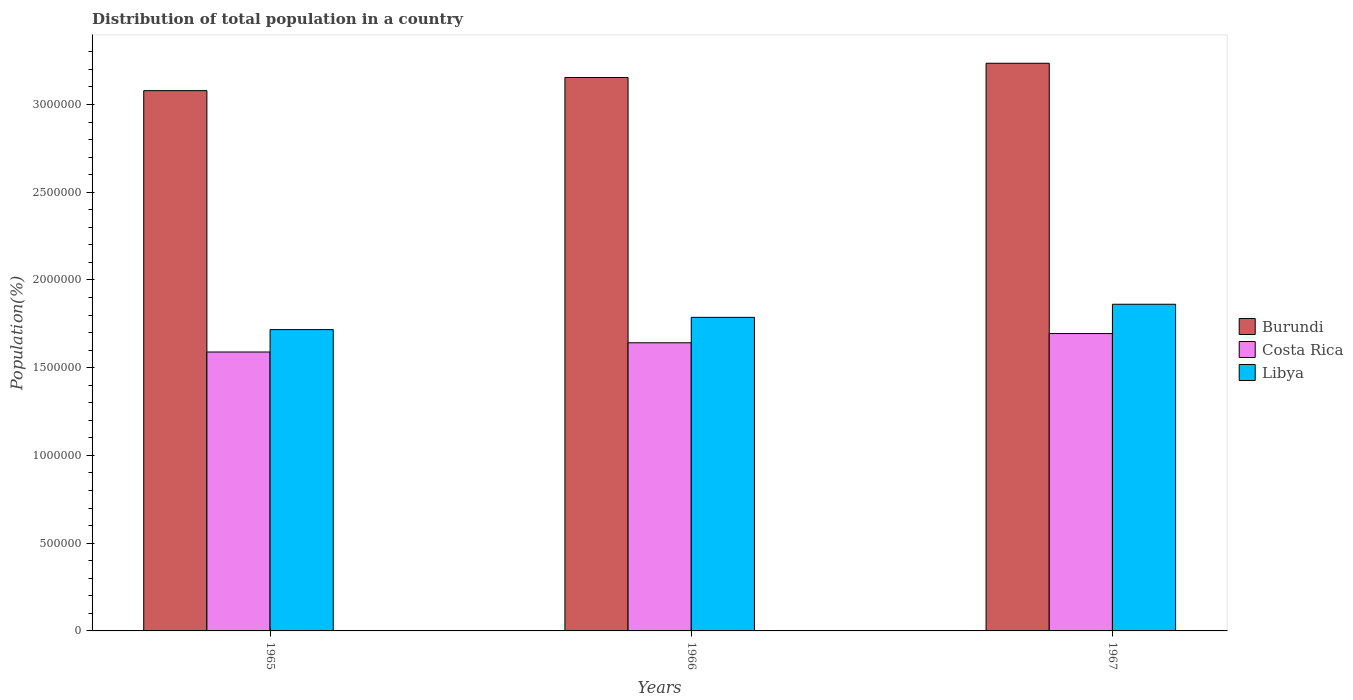How many different coloured bars are there?
Offer a very short reply. 3. Are the number of bars per tick equal to the number of legend labels?
Offer a terse response. Yes. What is the label of the 3rd group of bars from the left?
Offer a terse response. 1967. In how many cases, is the number of bars for a given year not equal to the number of legend labels?
Offer a terse response. 0. What is the population of in Burundi in 1965?
Offer a very short reply. 3.08e+06. Across all years, what is the maximum population of in Costa Rica?
Provide a short and direct response. 1.69e+06. Across all years, what is the minimum population of in Burundi?
Keep it short and to the point. 3.08e+06. In which year was the population of in Costa Rica maximum?
Offer a terse response. 1967. In which year was the population of in Costa Rica minimum?
Make the answer very short. 1965. What is the total population of in Costa Rica in the graph?
Offer a very short reply. 4.93e+06. What is the difference between the population of in Costa Rica in 1965 and that in 1966?
Provide a succinct answer. -5.26e+04. What is the difference between the population of in Costa Rica in 1965 and the population of in Libya in 1967?
Make the answer very short. -2.72e+05. What is the average population of in Libya per year?
Keep it short and to the point. 1.79e+06. In the year 1966, what is the difference between the population of in Libya and population of in Burundi?
Your answer should be compact. -1.37e+06. In how many years, is the population of in Burundi greater than 600000 %?
Your answer should be very brief. 3. What is the ratio of the population of in Costa Rica in 1966 to that in 1967?
Offer a terse response. 0.97. What is the difference between the highest and the second highest population of in Costa Rica?
Give a very brief answer. 5.25e+04. What is the difference between the highest and the lowest population of in Libya?
Your answer should be very brief. 1.44e+05. In how many years, is the population of in Burundi greater than the average population of in Burundi taken over all years?
Your answer should be compact. 1. What does the 1st bar from the left in 1965 represents?
Offer a very short reply. Burundi. What does the 1st bar from the right in 1967 represents?
Give a very brief answer. Libya. Is it the case that in every year, the sum of the population of in Libya and population of in Costa Rica is greater than the population of in Burundi?
Make the answer very short. Yes. How many bars are there?
Your answer should be very brief. 9. How many years are there in the graph?
Keep it short and to the point. 3. Does the graph contain any zero values?
Ensure brevity in your answer.  No. Does the graph contain grids?
Make the answer very short. No. Where does the legend appear in the graph?
Give a very brief answer. Center right. How are the legend labels stacked?
Keep it short and to the point. Vertical. What is the title of the graph?
Provide a succinct answer. Distribution of total population in a country. What is the label or title of the Y-axis?
Give a very brief answer. Population(%). What is the Population(%) of Burundi in 1965?
Provide a short and direct response. 3.08e+06. What is the Population(%) in Costa Rica in 1965?
Give a very brief answer. 1.59e+06. What is the Population(%) of Libya in 1965?
Your answer should be very brief. 1.72e+06. What is the Population(%) in Burundi in 1966?
Provide a succinct answer. 3.15e+06. What is the Population(%) in Costa Rica in 1966?
Your answer should be compact. 1.64e+06. What is the Population(%) in Libya in 1966?
Give a very brief answer. 1.79e+06. What is the Population(%) of Burundi in 1967?
Keep it short and to the point. 3.24e+06. What is the Population(%) in Costa Rica in 1967?
Your answer should be very brief. 1.69e+06. What is the Population(%) of Libya in 1967?
Provide a succinct answer. 1.86e+06. Across all years, what is the maximum Population(%) of Burundi?
Provide a short and direct response. 3.24e+06. Across all years, what is the maximum Population(%) in Costa Rica?
Keep it short and to the point. 1.69e+06. Across all years, what is the maximum Population(%) of Libya?
Keep it short and to the point. 1.86e+06. Across all years, what is the minimum Population(%) of Burundi?
Your response must be concise. 3.08e+06. Across all years, what is the minimum Population(%) in Costa Rica?
Your answer should be very brief. 1.59e+06. Across all years, what is the minimum Population(%) in Libya?
Ensure brevity in your answer.  1.72e+06. What is the total Population(%) in Burundi in the graph?
Your answer should be very brief. 9.47e+06. What is the total Population(%) of Costa Rica in the graph?
Your response must be concise. 4.93e+06. What is the total Population(%) in Libya in the graph?
Ensure brevity in your answer.  5.37e+06. What is the difference between the Population(%) of Burundi in 1965 and that in 1966?
Give a very brief answer. -7.48e+04. What is the difference between the Population(%) in Costa Rica in 1965 and that in 1966?
Your response must be concise. -5.26e+04. What is the difference between the Population(%) of Libya in 1965 and that in 1966?
Ensure brevity in your answer.  -6.98e+04. What is the difference between the Population(%) of Burundi in 1965 and that in 1967?
Your answer should be compact. -1.56e+05. What is the difference between the Population(%) in Costa Rica in 1965 and that in 1967?
Offer a terse response. -1.05e+05. What is the difference between the Population(%) in Libya in 1965 and that in 1967?
Offer a very short reply. -1.44e+05. What is the difference between the Population(%) in Burundi in 1966 and that in 1967?
Make the answer very short. -8.12e+04. What is the difference between the Population(%) of Costa Rica in 1966 and that in 1967?
Provide a short and direct response. -5.25e+04. What is the difference between the Population(%) in Libya in 1966 and that in 1967?
Provide a succinct answer. -7.46e+04. What is the difference between the Population(%) of Burundi in 1965 and the Population(%) of Costa Rica in 1966?
Keep it short and to the point. 1.44e+06. What is the difference between the Population(%) of Burundi in 1965 and the Population(%) of Libya in 1966?
Offer a very short reply. 1.29e+06. What is the difference between the Population(%) in Costa Rica in 1965 and the Population(%) in Libya in 1966?
Your answer should be very brief. -1.97e+05. What is the difference between the Population(%) of Burundi in 1965 and the Population(%) of Costa Rica in 1967?
Offer a very short reply. 1.38e+06. What is the difference between the Population(%) of Burundi in 1965 and the Population(%) of Libya in 1967?
Your answer should be very brief. 1.22e+06. What is the difference between the Population(%) of Costa Rica in 1965 and the Population(%) of Libya in 1967?
Your answer should be very brief. -2.72e+05. What is the difference between the Population(%) of Burundi in 1966 and the Population(%) of Costa Rica in 1967?
Your response must be concise. 1.46e+06. What is the difference between the Population(%) in Burundi in 1966 and the Population(%) in Libya in 1967?
Provide a succinct answer. 1.29e+06. What is the difference between the Population(%) in Costa Rica in 1966 and the Population(%) in Libya in 1967?
Keep it short and to the point. -2.19e+05. What is the average Population(%) in Burundi per year?
Offer a terse response. 3.16e+06. What is the average Population(%) of Costa Rica per year?
Offer a very short reply. 1.64e+06. What is the average Population(%) in Libya per year?
Offer a terse response. 1.79e+06. In the year 1965, what is the difference between the Population(%) of Burundi and Population(%) of Costa Rica?
Offer a terse response. 1.49e+06. In the year 1965, what is the difference between the Population(%) of Burundi and Population(%) of Libya?
Your answer should be compact. 1.36e+06. In the year 1965, what is the difference between the Population(%) of Costa Rica and Population(%) of Libya?
Your answer should be very brief. -1.28e+05. In the year 1966, what is the difference between the Population(%) of Burundi and Population(%) of Costa Rica?
Offer a very short reply. 1.51e+06. In the year 1966, what is the difference between the Population(%) of Burundi and Population(%) of Libya?
Your answer should be very brief. 1.37e+06. In the year 1966, what is the difference between the Population(%) in Costa Rica and Population(%) in Libya?
Your answer should be very brief. -1.45e+05. In the year 1967, what is the difference between the Population(%) in Burundi and Population(%) in Costa Rica?
Keep it short and to the point. 1.54e+06. In the year 1967, what is the difference between the Population(%) of Burundi and Population(%) of Libya?
Give a very brief answer. 1.37e+06. In the year 1967, what is the difference between the Population(%) of Costa Rica and Population(%) of Libya?
Give a very brief answer. -1.67e+05. What is the ratio of the Population(%) of Burundi in 1965 to that in 1966?
Offer a very short reply. 0.98. What is the ratio of the Population(%) in Costa Rica in 1965 to that in 1966?
Your answer should be compact. 0.97. What is the ratio of the Population(%) of Libya in 1965 to that in 1966?
Your response must be concise. 0.96. What is the ratio of the Population(%) in Burundi in 1965 to that in 1967?
Provide a succinct answer. 0.95. What is the ratio of the Population(%) of Costa Rica in 1965 to that in 1967?
Provide a succinct answer. 0.94. What is the ratio of the Population(%) in Libya in 1965 to that in 1967?
Make the answer very short. 0.92. What is the ratio of the Population(%) in Burundi in 1966 to that in 1967?
Your response must be concise. 0.97. What is the ratio of the Population(%) in Costa Rica in 1966 to that in 1967?
Your answer should be very brief. 0.97. What is the ratio of the Population(%) in Libya in 1966 to that in 1967?
Make the answer very short. 0.96. What is the difference between the highest and the second highest Population(%) in Burundi?
Your response must be concise. 8.12e+04. What is the difference between the highest and the second highest Population(%) in Costa Rica?
Your answer should be very brief. 5.25e+04. What is the difference between the highest and the second highest Population(%) in Libya?
Offer a terse response. 7.46e+04. What is the difference between the highest and the lowest Population(%) of Burundi?
Ensure brevity in your answer.  1.56e+05. What is the difference between the highest and the lowest Population(%) in Costa Rica?
Provide a short and direct response. 1.05e+05. What is the difference between the highest and the lowest Population(%) of Libya?
Your response must be concise. 1.44e+05. 